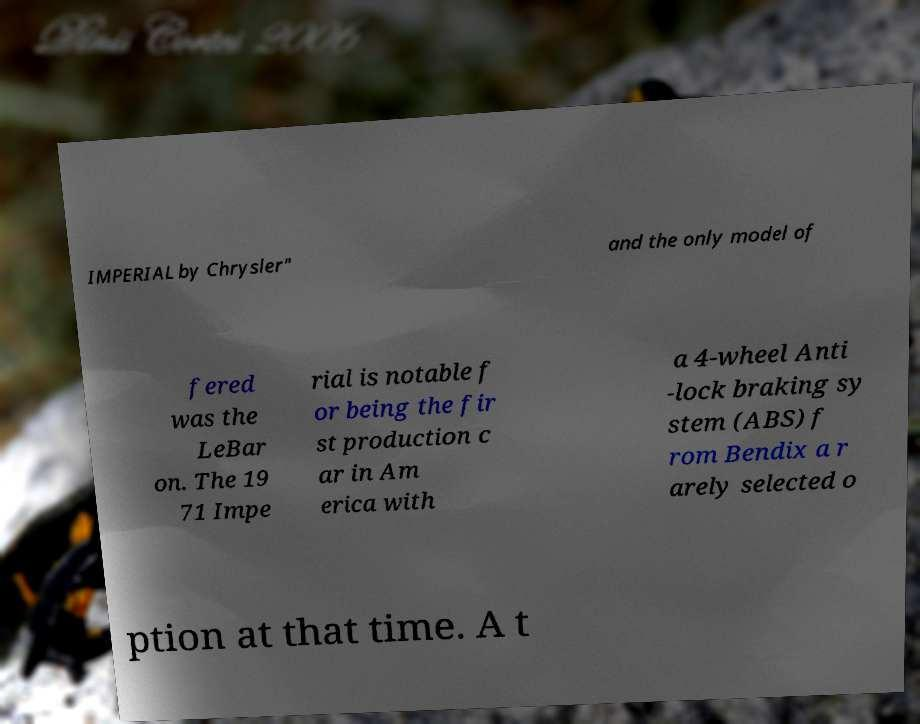I need the written content from this picture converted into text. Can you do that? IMPERIAL by Chrysler" and the only model of fered was the LeBar on. The 19 71 Impe rial is notable f or being the fir st production c ar in Am erica with a 4-wheel Anti -lock braking sy stem (ABS) f rom Bendix a r arely selected o ption at that time. A t 